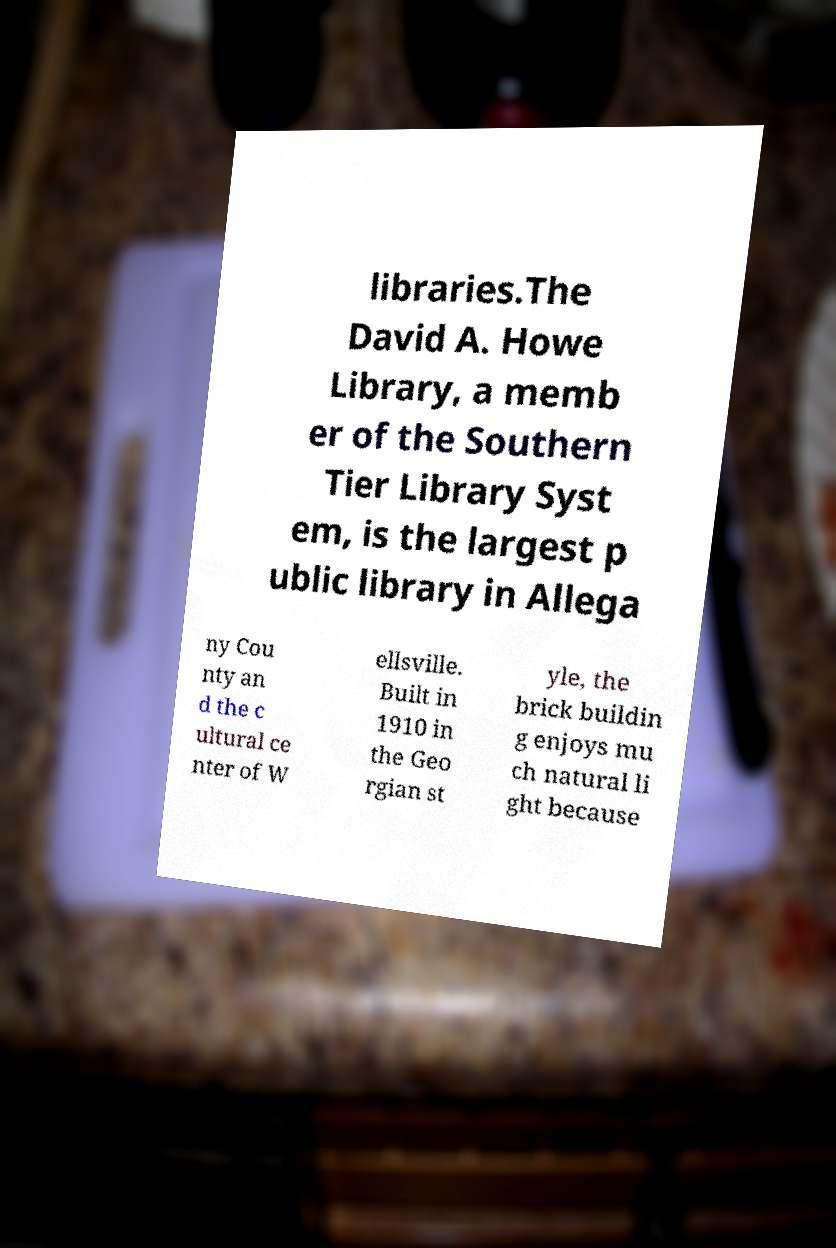I need the written content from this picture converted into text. Can you do that? libraries.The David A. Howe Library, a memb er of the Southern Tier Library Syst em, is the largest p ublic library in Allega ny Cou nty an d the c ultural ce nter of W ellsville. Built in 1910 in the Geo rgian st yle, the brick buildin g enjoys mu ch natural li ght because 